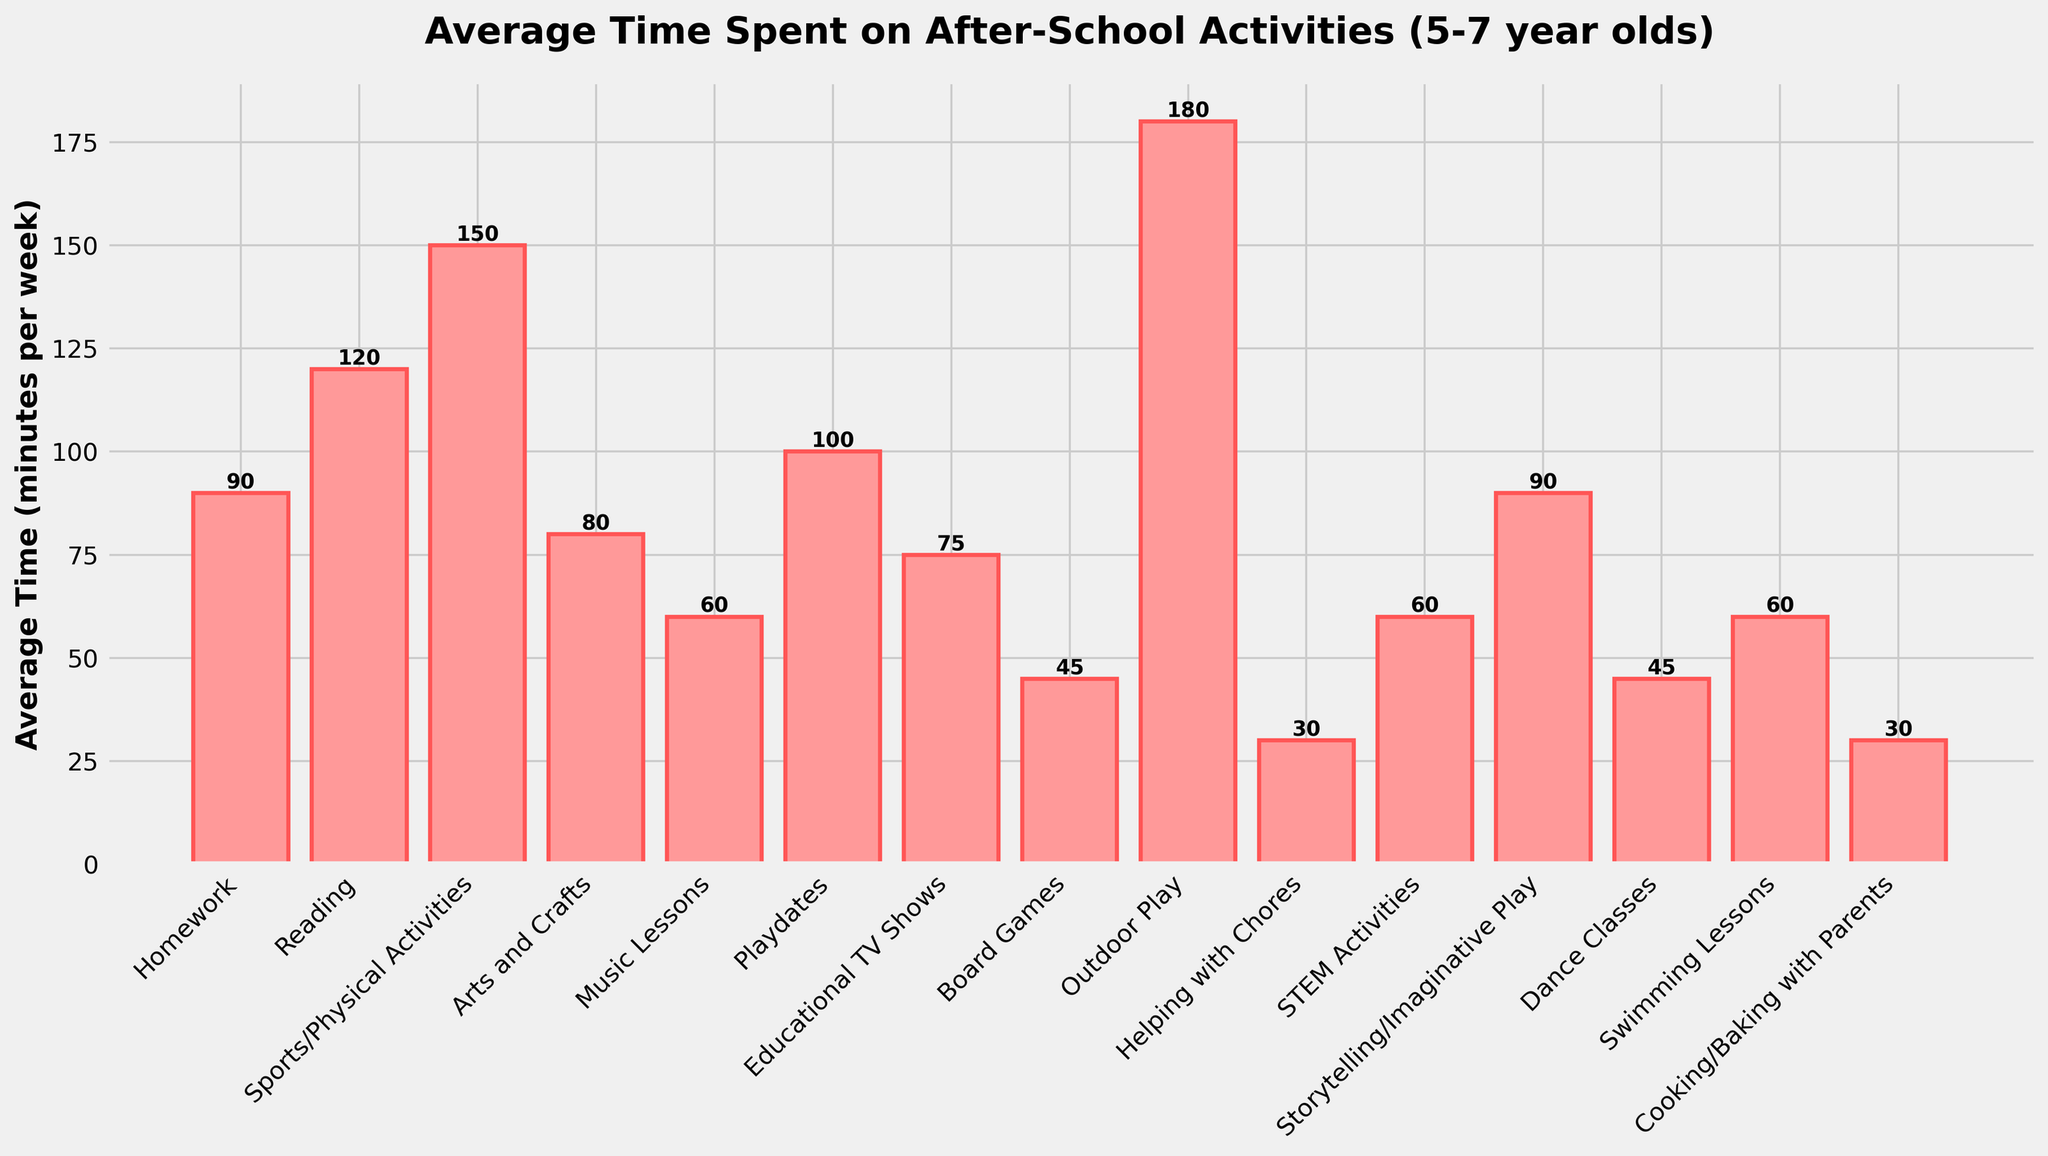Which activity has the highest average time spent? Observing the figure, the activity with the tallest bar represents the highest average time spent. In this case, it is "Outdoor Play."
Answer: Outdoor Play Which activity has the lowest average time spent? The activity with the shortest bar indicates the lowest average time spent. Here, it's "Helping with Chores."
Answer: Helping with Chores What is the total average time spent on Homework, Reading, and Sports/Physical Activities combined? Add the average times spent on Homework, Reading, and Sports/Physical Activities: 90 + 120 + 150 = 360 minutes per week.
Answer: 360 minutes How much more time is spent on Outdoor Play compared to STEM Activities? Subtract the average time spent on STEM Activities from the average time spent on Outdoor Play: 180 - 60 = 120 minutes per week.
Answer: 120 minutes Are children spending more time on Playdates or on Reading? Compare the heights of the bars for Playdates and Reading. The bar for Reading is taller, meaning more time is spent on Reading.
Answer: Reading What is the average time spent on the three least popular activities? Find the three activities with the shortest bars (Helping with Chores, Cooking/Baking with Parents, and Board Games): (30 + 30 + 45) / 3 = 35 minutes per week.
Answer: 35 minutes Which two activities have an equal average time spent, and what is that amount? By checking visually, Music Lessons and STEM Activities have equal bar heights, each representing 60 minutes per week.
Answer: Music Lessons and STEM Activities, 60 minutes How does the time spent on Dance Classes compare to that on Board Games? Compare the heights of the bars for Dance Classes and Board Games. Both have a height of 45 minutes per week, indicating equal time spent.
Answer: Equal How much time in total is spent on the top two most popular activities? Identify the top two activities (Outdoor Play and Sports/Physical Activities) and sum their times: 180 + 150 = 330 minutes per week.
Answer: 330 minutes Is the time spent on Homework closer to the time spent on Storytelling/Imaginative Play or on Playdates? Compare the differences: Homework (90) and Storytelling/Imaginative Play (90) have no difference, whereas Homework and Playdates (100) differ by 10 minutes. Hence, Homework is closer to Storytelling/Imaginative Play.
Answer: Storytelling/Imaginative Play 